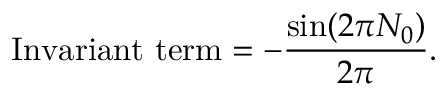Convert formula to latex. <formula><loc_0><loc_0><loc_500><loc_500>I n v a r i a n t t e r m = - \frac { \sin ( 2 \pi N _ { 0 } ) } { 2 \pi } .</formula> 